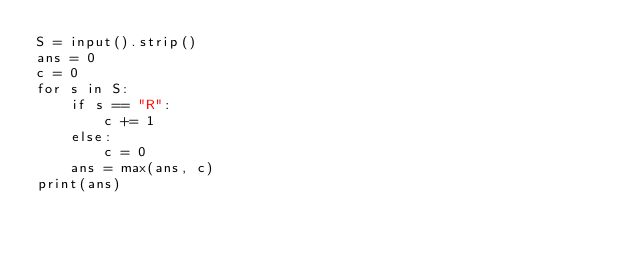<code> <loc_0><loc_0><loc_500><loc_500><_Python_>S = input().strip()
ans = 0
c = 0
for s in S:
    if s == "R":
        c += 1
    else:
        c = 0
    ans = max(ans, c)
print(ans)
</code> 